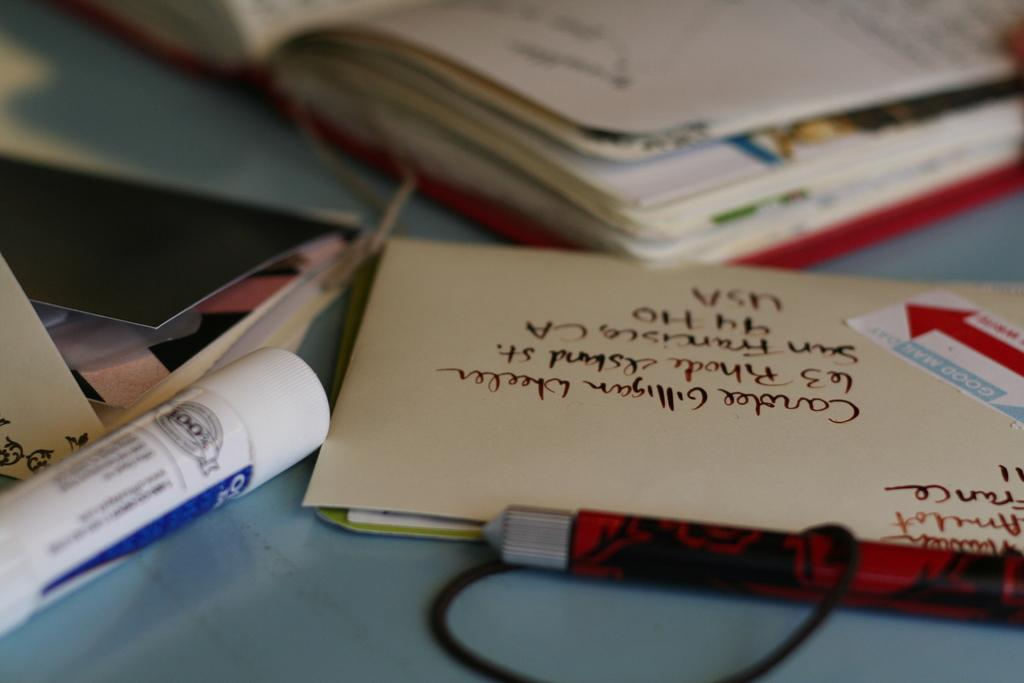<image>
Provide a brief description of the given image. The envelope is being mailed to San Francisco California. 